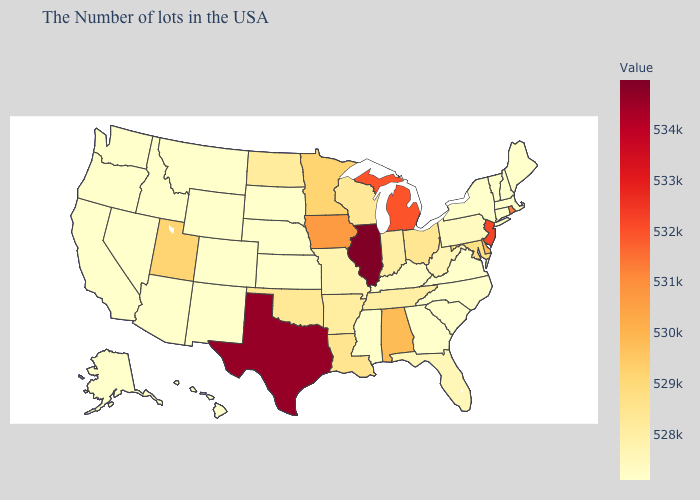Does Vermont have the highest value in the Northeast?
Write a very short answer. No. Among the states that border Louisiana , which have the lowest value?
Short answer required. Mississippi. 